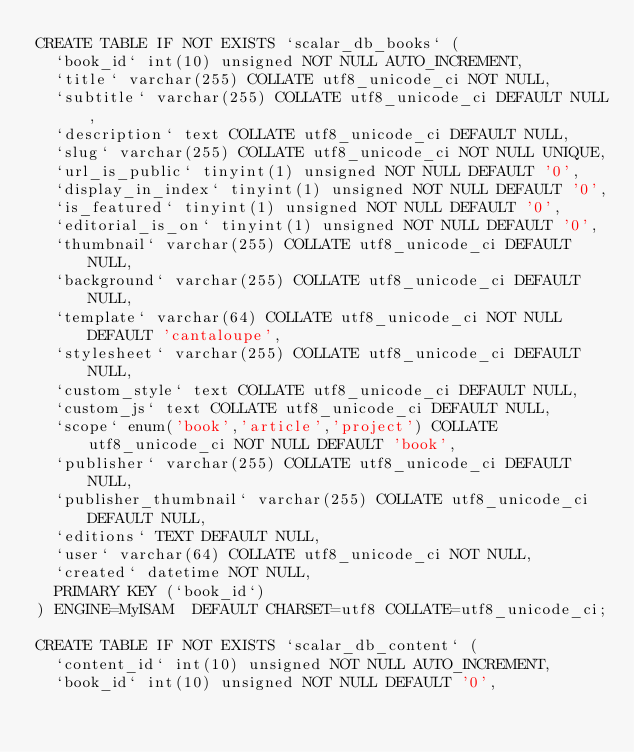Convert code to text. <code><loc_0><loc_0><loc_500><loc_500><_SQL_>CREATE TABLE IF NOT EXISTS `scalar_db_books` (
  `book_id` int(10) unsigned NOT NULL AUTO_INCREMENT,
  `title` varchar(255) COLLATE utf8_unicode_ci NOT NULL,
  `subtitle` varchar(255) COLLATE utf8_unicode_ci DEFAULT NULL,
  `description` text COLLATE utf8_unicode_ci DEFAULT NULL,
  `slug` varchar(255) COLLATE utf8_unicode_ci NOT NULL UNIQUE,
  `url_is_public` tinyint(1) unsigned NOT NULL DEFAULT '0',
  `display_in_index` tinyint(1) unsigned NOT NULL DEFAULT '0',
  `is_featured` tinyint(1) unsigned NOT NULL DEFAULT '0',
  `editorial_is_on` tinyint(1) unsigned NOT NULL DEFAULT '0',
  `thumbnail` varchar(255) COLLATE utf8_unicode_ci DEFAULT NULL,
  `background` varchar(255) COLLATE utf8_unicode_ci DEFAULT NULL,
  `template` varchar(64) COLLATE utf8_unicode_ci NOT NULL DEFAULT 'cantaloupe',
  `stylesheet` varchar(255) COLLATE utf8_unicode_ci DEFAULT NULL,
  `custom_style` text COLLATE utf8_unicode_ci DEFAULT NULL,
  `custom_js` text COLLATE utf8_unicode_ci DEFAULT NULL,
  `scope` enum('book','article','project') COLLATE utf8_unicode_ci NOT NULL DEFAULT 'book',
  `publisher` varchar(255) COLLATE utf8_unicode_ci DEFAULT NULL,
  `publisher_thumbnail` varchar(255) COLLATE utf8_unicode_ci DEFAULT NULL,
  `editions` TEXT DEFAULT NULL,
  `user` varchar(64) COLLATE utf8_unicode_ci NOT NULL,
  `created` datetime NOT NULL,
  PRIMARY KEY (`book_id`)
) ENGINE=MyISAM  DEFAULT CHARSET=utf8 COLLATE=utf8_unicode_ci;

CREATE TABLE IF NOT EXISTS `scalar_db_content` (
  `content_id` int(10) unsigned NOT NULL AUTO_INCREMENT,
  `book_id` int(10) unsigned NOT NULL DEFAULT '0',</code> 